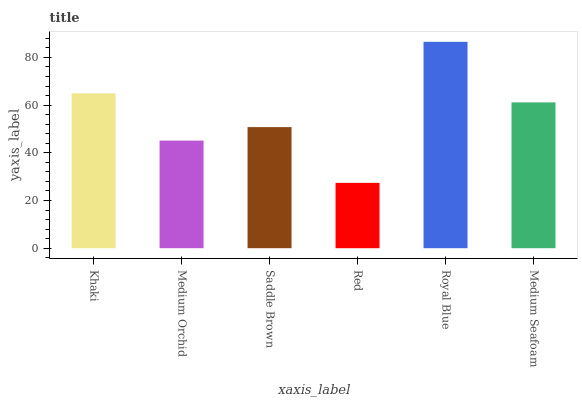Is Red the minimum?
Answer yes or no. Yes. Is Royal Blue the maximum?
Answer yes or no. Yes. Is Medium Orchid the minimum?
Answer yes or no. No. Is Medium Orchid the maximum?
Answer yes or no. No. Is Khaki greater than Medium Orchid?
Answer yes or no. Yes. Is Medium Orchid less than Khaki?
Answer yes or no. Yes. Is Medium Orchid greater than Khaki?
Answer yes or no. No. Is Khaki less than Medium Orchid?
Answer yes or no. No. Is Medium Seafoam the high median?
Answer yes or no. Yes. Is Saddle Brown the low median?
Answer yes or no. Yes. Is Saddle Brown the high median?
Answer yes or no. No. Is Royal Blue the low median?
Answer yes or no. No. 